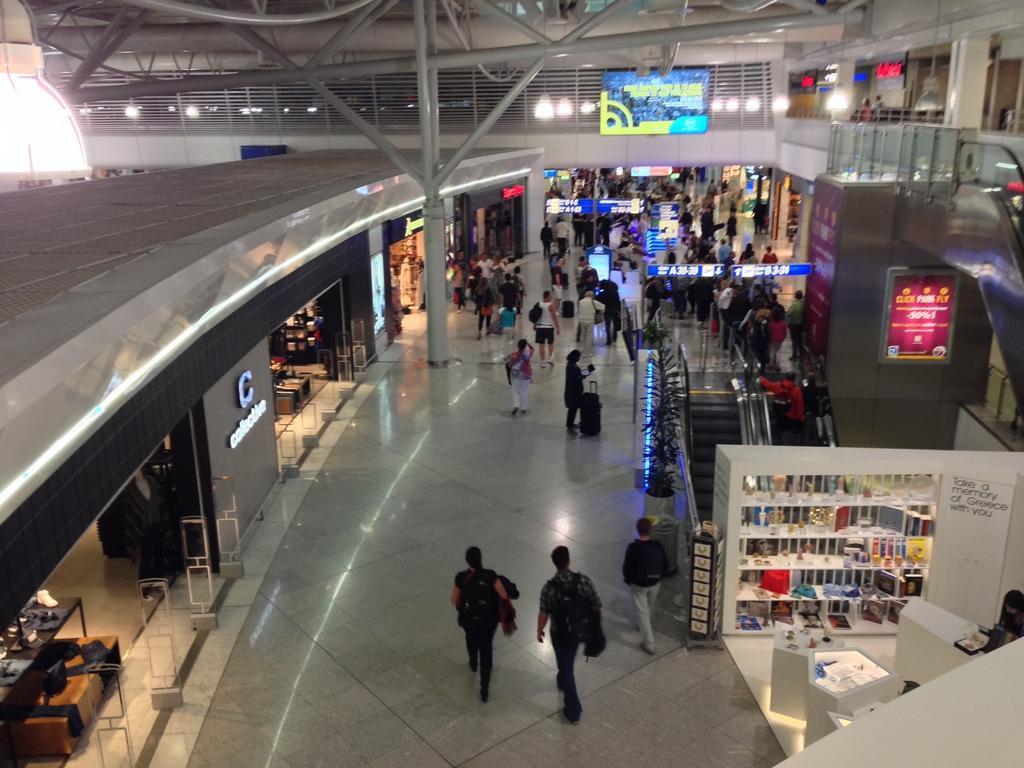In one or two sentences, can you explain what this image depicts? In this image, there are a few people. We can see the ground with some objects. We can see some escalators. We can also see some stories and a table with some objects on the left. We can see some shelves with objects. We can see a few display screens and a plant. We can see some lights. We can also see some objects on the right. 